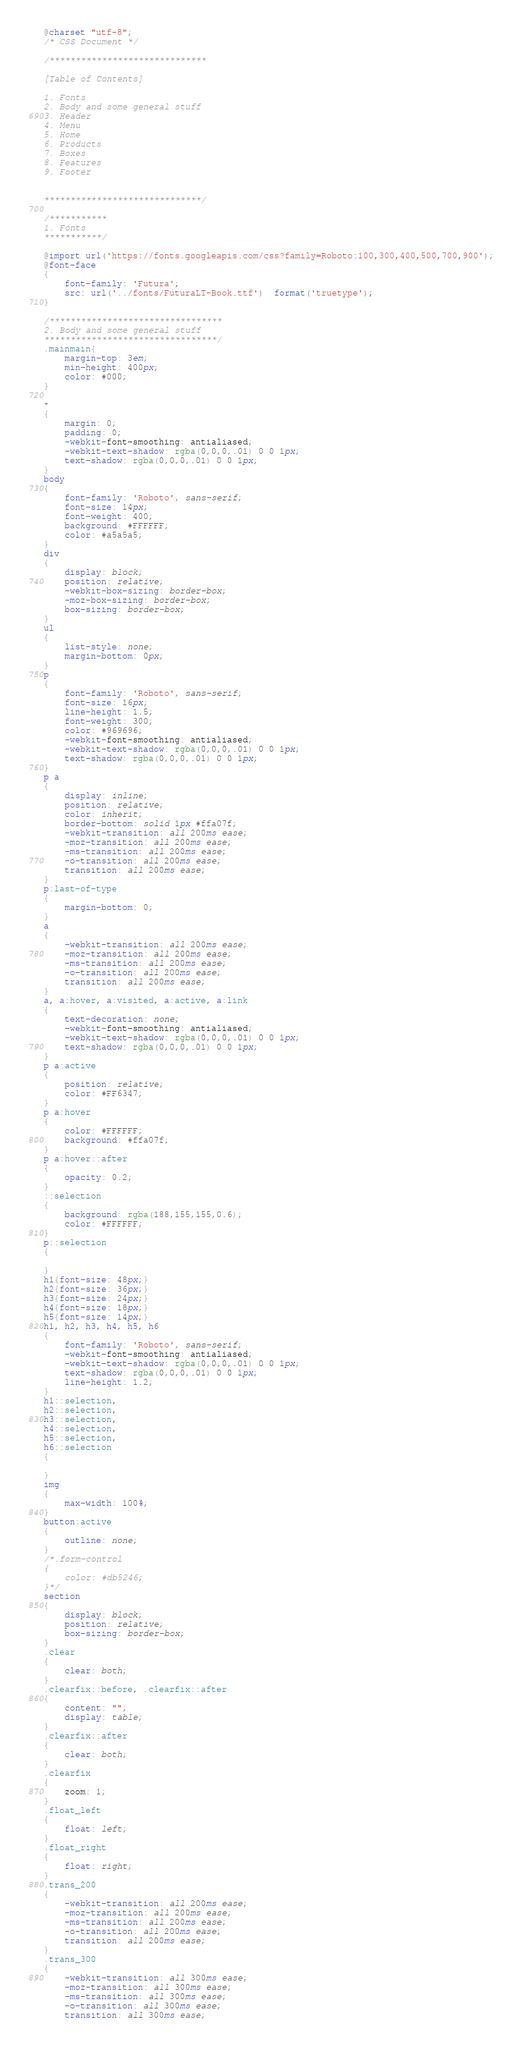Convert code to text. <code><loc_0><loc_0><loc_500><loc_500><_CSS_>@charset "utf-8";
/* CSS Document */

/******************************

[Table of Contents]

1. Fonts
2. Body and some general stuff
3. Header
4. Menu
5. Home
6. Products
7. Boxes
8. Features
9. Footer


******************************/

/***********
1. Fonts
***********/

@import url('https://fonts.googleapis.com/css?family=Roboto:100,300,400,500,700,900');
@font-face
{
	font-family: 'Futura';
	src: url('../fonts/FuturaLT-Book.ttf')  format('truetype');
}

/*********************************
2. Body and some general stuff
*********************************/
.mainmain{
    margin-top: 3em;
    min-height: 400px;
    color: #000;
}

*
{
	margin: 0;
	padding: 0;
	-webkit-font-smoothing: antialiased;
	-webkit-text-shadow: rgba(0,0,0,.01) 0 0 1px;
	text-shadow: rgba(0,0,0,.01) 0 0 1px;
}
body
{
	font-family: 'Roboto', sans-serif;
	font-size: 14px;
	font-weight: 400;
	background: #FFFFFF;
	color: #a5a5a5;
}
div
{
	display: block;
	position: relative;
	-webkit-box-sizing: border-box;
    -moz-box-sizing: border-box;
    box-sizing: border-box;
}
ul
{
	list-style: none;
	margin-bottom: 0px;
}
p
{
	font-family: 'Roboto', sans-serif;
	font-size: 16px;
	line-height: 1.5;
	font-weight: 300;
	color: #969696;
	-webkit-font-smoothing: antialiased;
	-webkit-text-shadow: rgba(0,0,0,.01) 0 0 1px;
	text-shadow: rgba(0,0,0,.01) 0 0 1px;
}
p a
{
	display: inline;
	position: relative;
	color: inherit;
	border-bottom: solid 1px #ffa07f;
	-webkit-transition: all 200ms ease;
	-moz-transition: all 200ms ease;
	-ms-transition: all 200ms ease;
	-o-transition: all 200ms ease;
	transition: all 200ms ease;
}
p:last-of-type
{
	margin-bottom: 0;
}
a
{
	-webkit-transition: all 200ms ease;
	-moz-transition: all 200ms ease;
	-ms-transition: all 200ms ease;
	-o-transition: all 200ms ease;
	transition: all 200ms ease;
}
a, a:hover, a:visited, a:active, a:link
{
	text-decoration: none;
	-webkit-font-smoothing: antialiased;
	-webkit-text-shadow: rgba(0,0,0,.01) 0 0 1px;
	text-shadow: rgba(0,0,0,.01) 0 0 1px;
}
p a:active
{
	position: relative;
	color: #FF6347;
}
p a:hover
{
	color: #FFFFFF;
	background: #ffa07f;
}
p a:hover::after
{
	opacity: 0.2;
}
::selection
{
	background: rgba(188,155,155,0.6);
	color: #FFFFFF;
}
p::selection
{
	
}
h1{font-size: 48px;}
h2{font-size: 36px;}
h3{font-size: 24px;}
h4{font-size: 18px;}
h5{font-size: 14px;}
h1, h2, h3, h4, h5, h6
{
	font-family: 'Roboto', sans-serif;
	-webkit-font-smoothing: antialiased;
	-webkit-text-shadow: rgba(0,0,0,.01) 0 0 1px;
	text-shadow: rgba(0,0,0,.01) 0 0 1px;
	line-height: 1.2;
}
h1::selection, 
h2::selection, 
h3::selection, 
h4::selection, 
h5::selection, 
h6::selection
{
	
}
img
{
	max-width: 100%;
}
button:active
{
	outline: none;
}
/*.form-control
{
	color: #db5246;
}*/
section
{
	display: block;
	position: relative;
	box-sizing: border-box;
}
.clear
{
	clear: both;
}
.clearfix::before, .clearfix::after
{
	content: "";
	display: table;
}
.clearfix::after
{
	clear: both;
}
.clearfix
{
	zoom: 1;
}
.float_left
{
	float: left;
}
.float_right
{
	float: right;
}
.trans_200
{
	-webkit-transition: all 200ms ease;
	-moz-transition: all 200ms ease;
	-ms-transition: all 200ms ease;
	-o-transition: all 200ms ease;
	transition: all 200ms ease;
}
.trans_300
{
	-webkit-transition: all 300ms ease;
	-moz-transition: all 300ms ease;
	-ms-transition: all 300ms ease;
	-o-transition: all 300ms ease;
	transition: all 300ms ease;</code> 